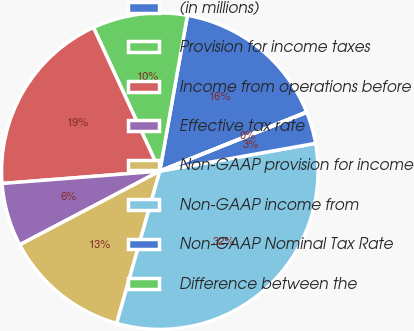Convert chart to OTSL. <chart><loc_0><loc_0><loc_500><loc_500><pie_chart><fcel>(in millions)<fcel>Provision for income taxes<fcel>Income from operations before<fcel>Effective tax rate<fcel>Non-GAAP provision for income<fcel>Non-GAAP income from<fcel>Non-GAAP Nominal Tax Rate<fcel>Difference between the<nl><fcel>16.12%<fcel>9.68%<fcel>19.36%<fcel>6.46%<fcel>12.9%<fcel>32.21%<fcel>3.25%<fcel>0.03%<nl></chart> 